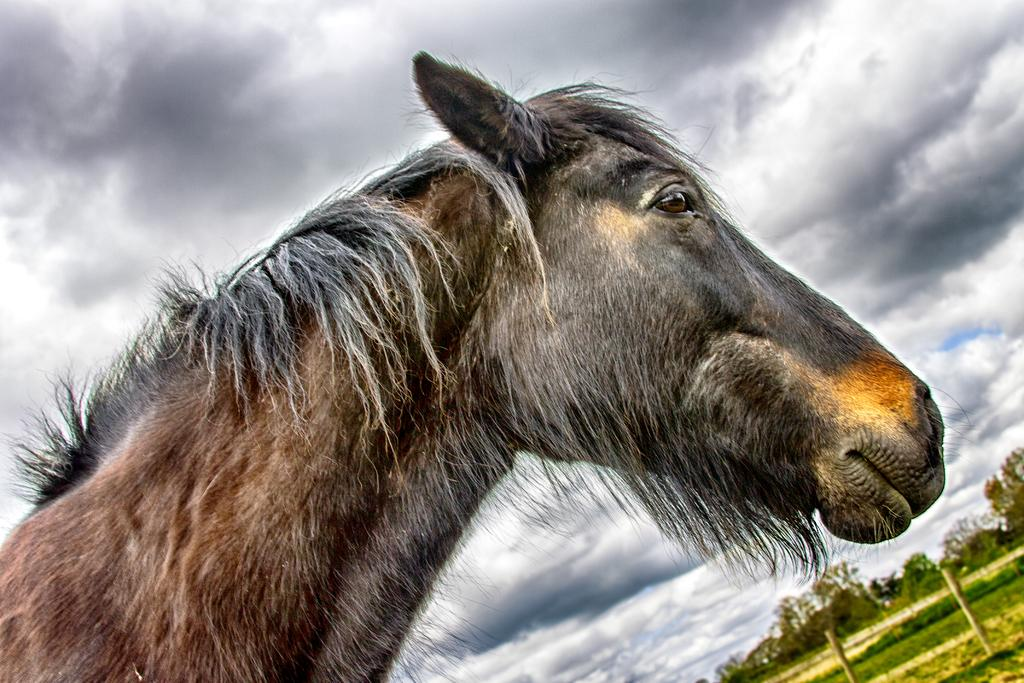What type of animal is in the image? There is an animal in the image, but the specific type cannot be determined from the provided facts. What type of vegetation is present in the image? There are trees, bushes, and green grass on the ground in the image. What structures can be seen in the image? There are poles visible in the image. What is the condition of the sky in the image? The sky is cloudy and visible at the top of the image. What type of produce is being harvested by the animal in the image? There is no produce being harvested in the image, nor is there any indication of an animal performing such an action. 